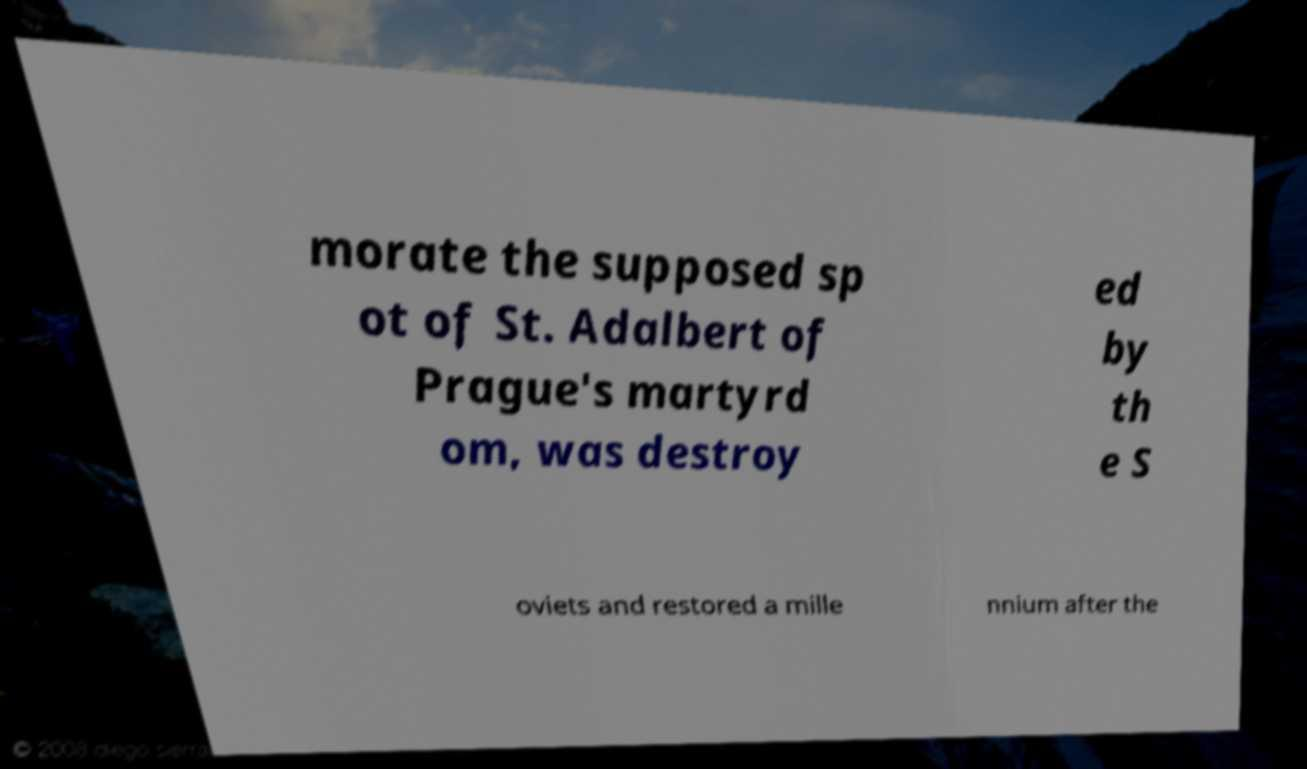For documentation purposes, I need the text within this image transcribed. Could you provide that? morate the supposed sp ot of St. Adalbert of Prague's martyrd om, was destroy ed by th e S oviets and restored a mille nnium after the 